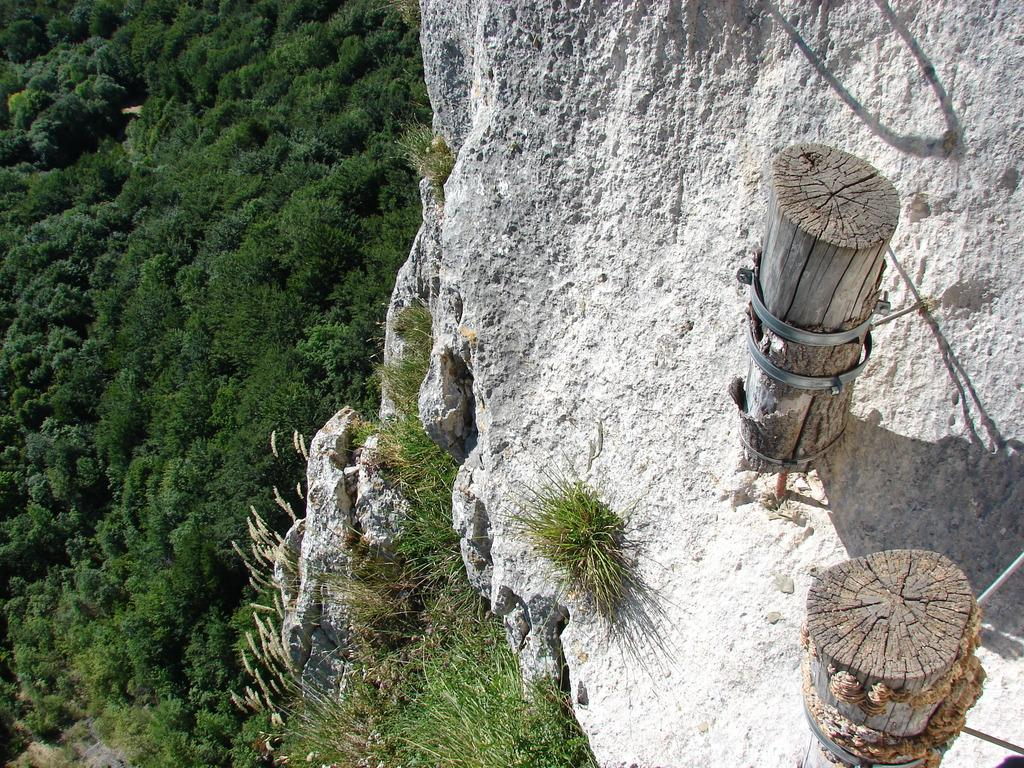What objects are placed on the rock in the image? There are two wooden sticks placed on a rock on the right side of the image. What type of vegetation can be seen on the left side of the image? There are trees on the left side of the image. What is the taste of the wind in the image? There is no mention of wind or taste in the image, so it is not possible to answer that question. 